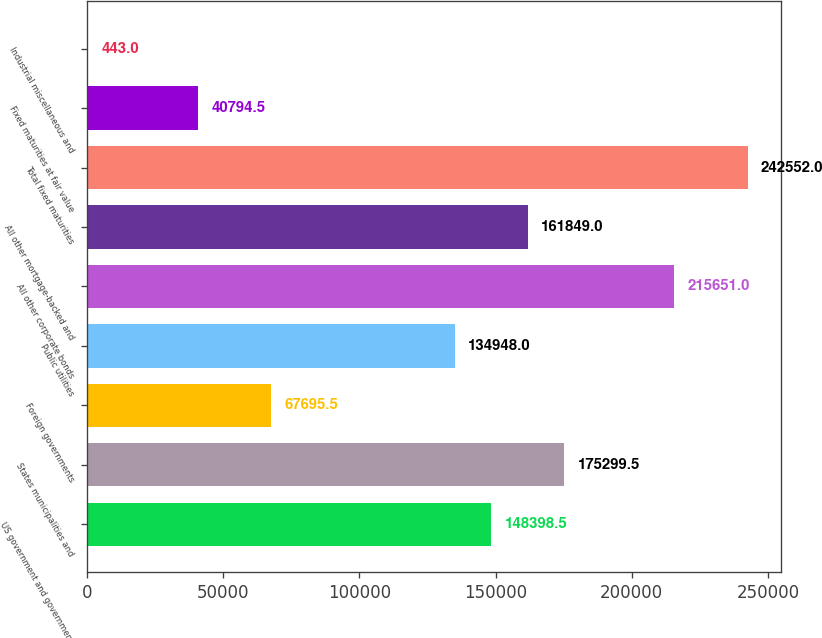Convert chart. <chart><loc_0><loc_0><loc_500><loc_500><bar_chart><fcel>US government and government<fcel>States municipalities and<fcel>Foreign governments<fcel>Public utilities<fcel>All other corporate bonds<fcel>All other mortgage-backed and<fcel>Total fixed maturities<fcel>Fixed maturities at fair value<fcel>Industrial miscellaneous and<nl><fcel>148398<fcel>175300<fcel>67695.5<fcel>134948<fcel>215651<fcel>161849<fcel>242552<fcel>40794.5<fcel>443<nl></chart> 